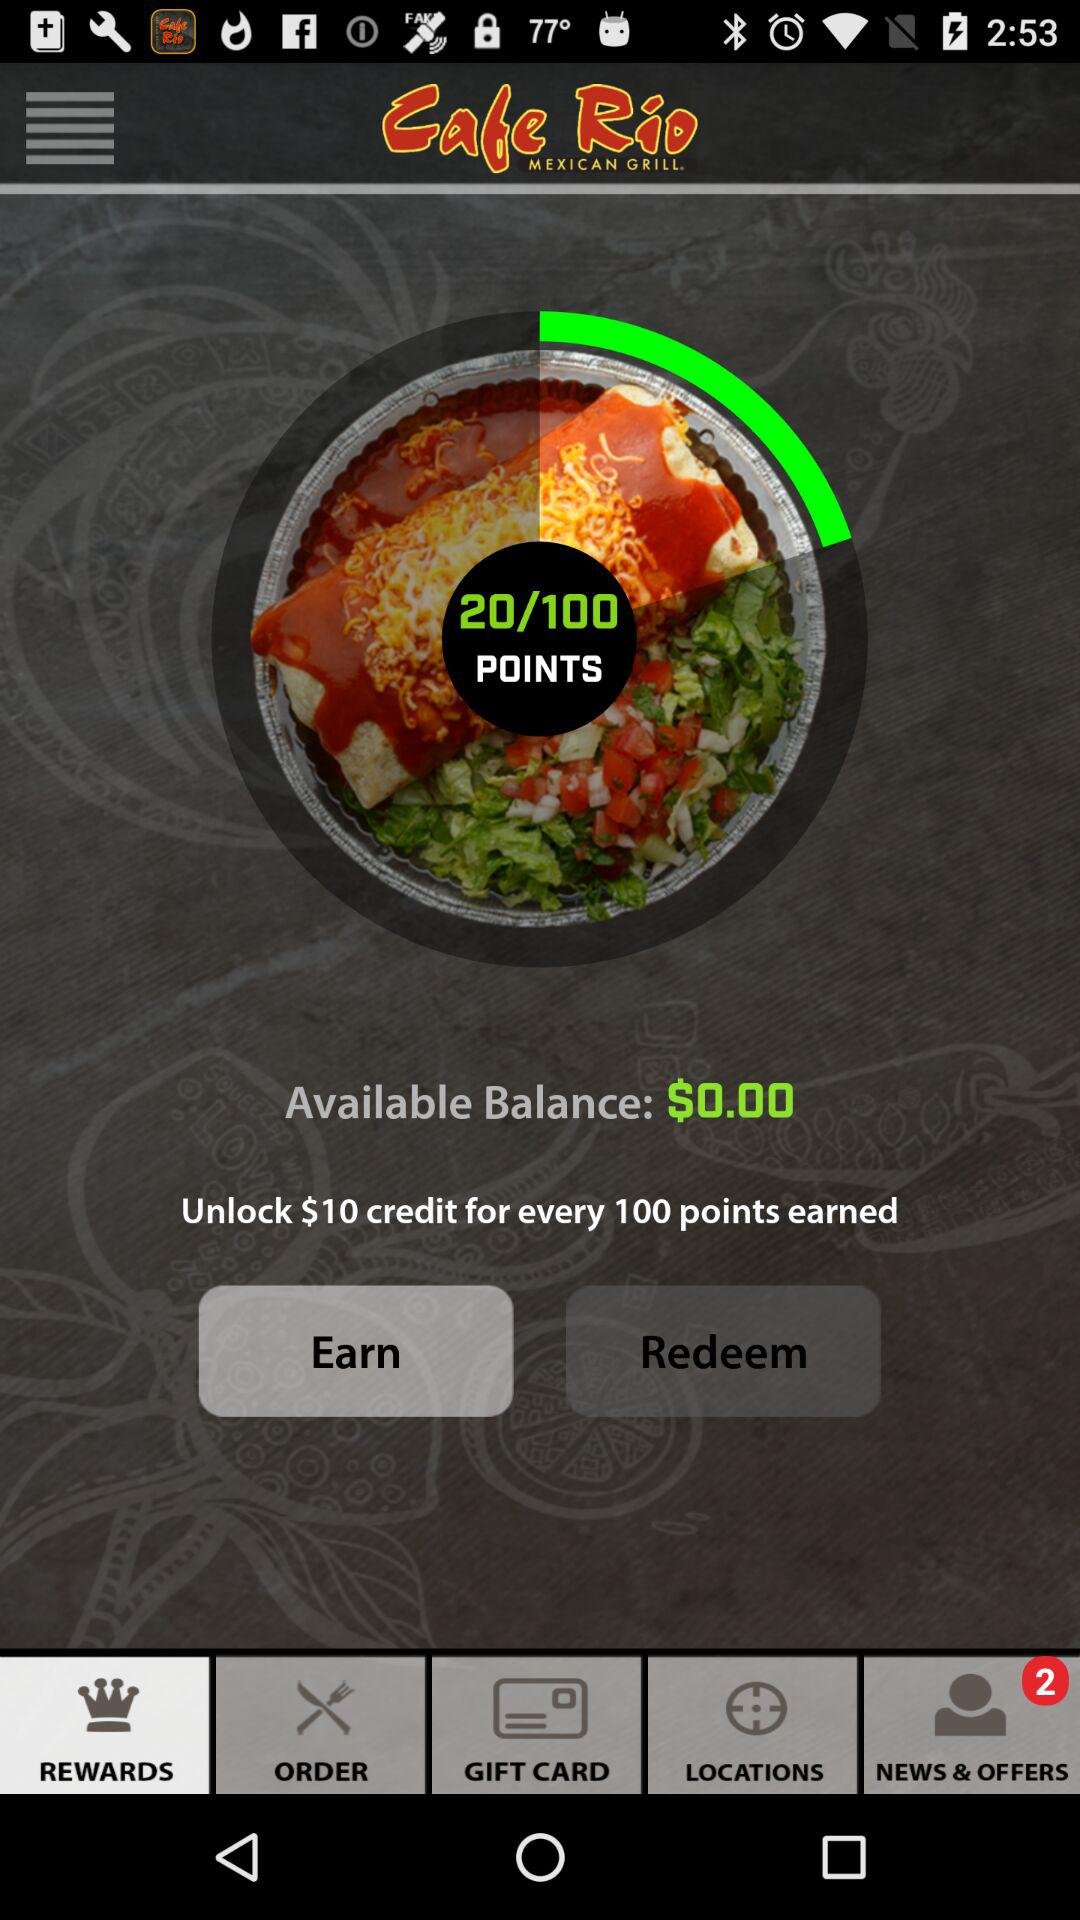How many points do I need to earn in order to redeem a $10 credit? To redeem a $10 credit, you need to accrue a total of 100 points within the rewards program, as shown on the app's display. 